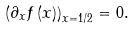Convert formula to latex. <formula><loc_0><loc_0><loc_500><loc_500>\left ( \partial _ { x } f \left ( x \right ) \right ) _ { x = 1 / 2 } = 0 .</formula> 